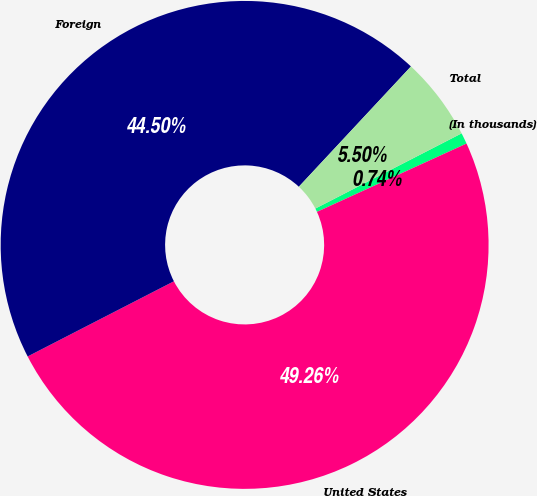Convert chart. <chart><loc_0><loc_0><loc_500><loc_500><pie_chart><fcel>(In thousands)<fcel>United States<fcel>Foreign<fcel>Total<nl><fcel>0.74%<fcel>49.26%<fcel>44.5%<fcel>5.5%<nl></chart> 